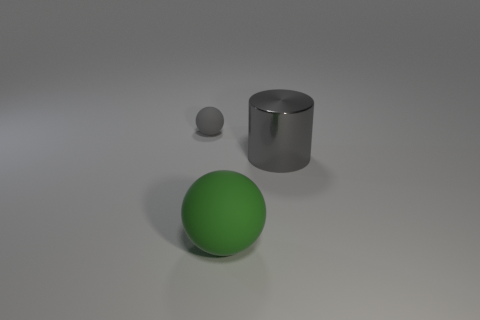Is there any other thing that is made of the same material as the big gray object?
Your response must be concise. No. What number of objects are either balls or large matte things?
Keep it short and to the point. 2. How many things are to the left of the big metal cylinder and behind the large green sphere?
Offer a very short reply. 1. Are there fewer tiny balls that are in front of the big gray object than purple shiny cylinders?
Keep it short and to the point. No. There is a green matte object that is the same size as the cylinder; what shape is it?
Offer a terse response. Sphere. How many other objects are there of the same color as the small matte object?
Keep it short and to the point. 1. Do the gray rubber sphere and the metallic thing have the same size?
Offer a very short reply. No. What number of objects are big rubber spheres or rubber things that are in front of the small rubber thing?
Make the answer very short. 1. Are there fewer green things on the right side of the big metal object than shiny cylinders in front of the big sphere?
Make the answer very short. No. How many other objects are there of the same material as the cylinder?
Provide a short and direct response. 0. 